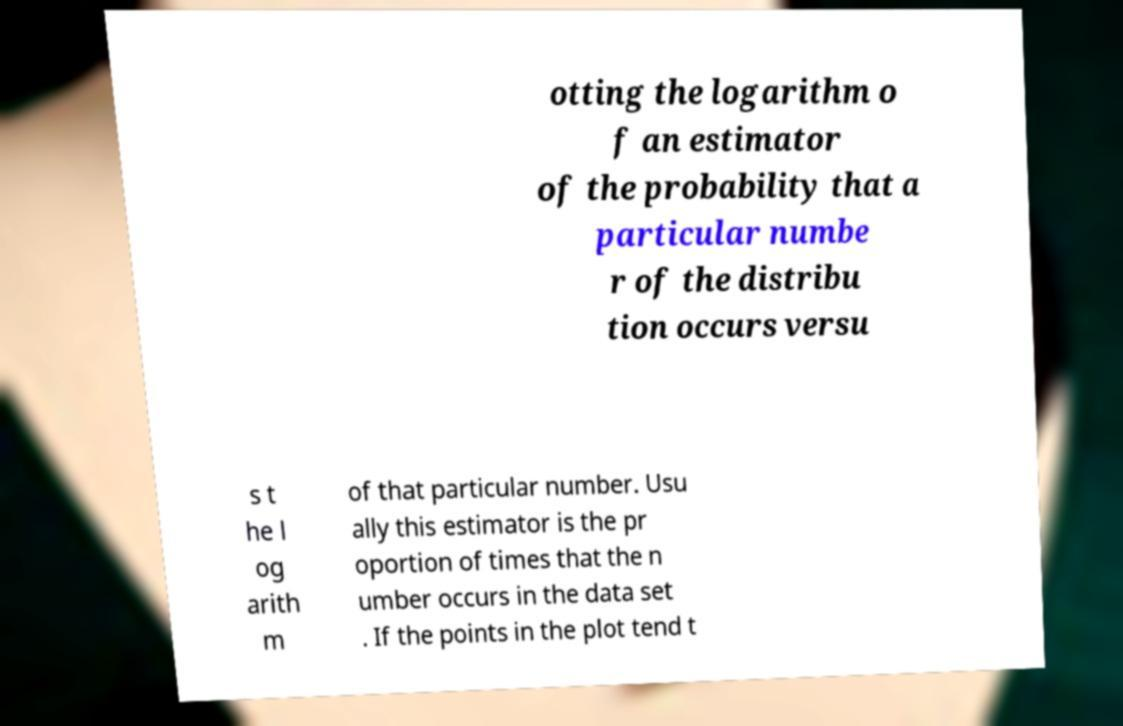Could you assist in decoding the text presented in this image and type it out clearly? otting the logarithm o f an estimator of the probability that a particular numbe r of the distribu tion occurs versu s t he l og arith m of that particular number. Usu ally this estimator is the pr oportion of times that the n umber occurs in the data set . If the points in the plot tend t 